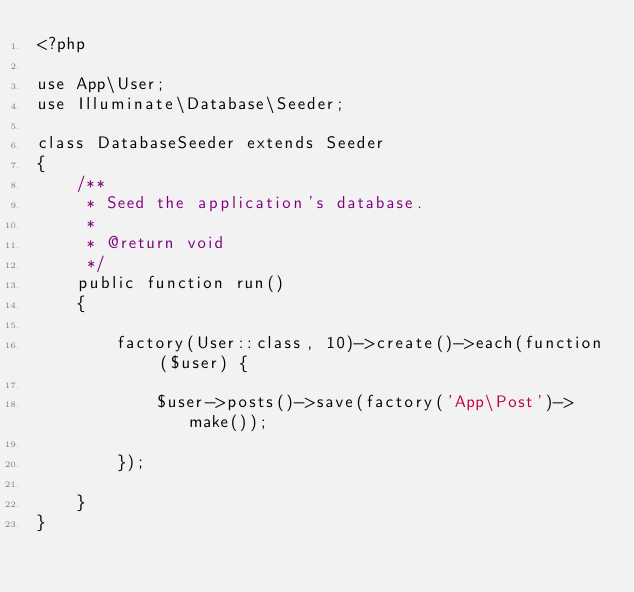<code> <loc_0><loc_0><loc_500><loc_500><_PHP_><?php

use App\User;
use Illuminate\Database\Seeder;

class DatabaseSeeder extends Seeder
{
    /**
     * Seed the application's database.
     *
     * @return void
     */
    public function run()
    {

        factory(User::class, 10)->create()->each(function ($user) {

            $user->posts()->save(factory('App\Post')->make());

        });
        
    }
}
</code> 